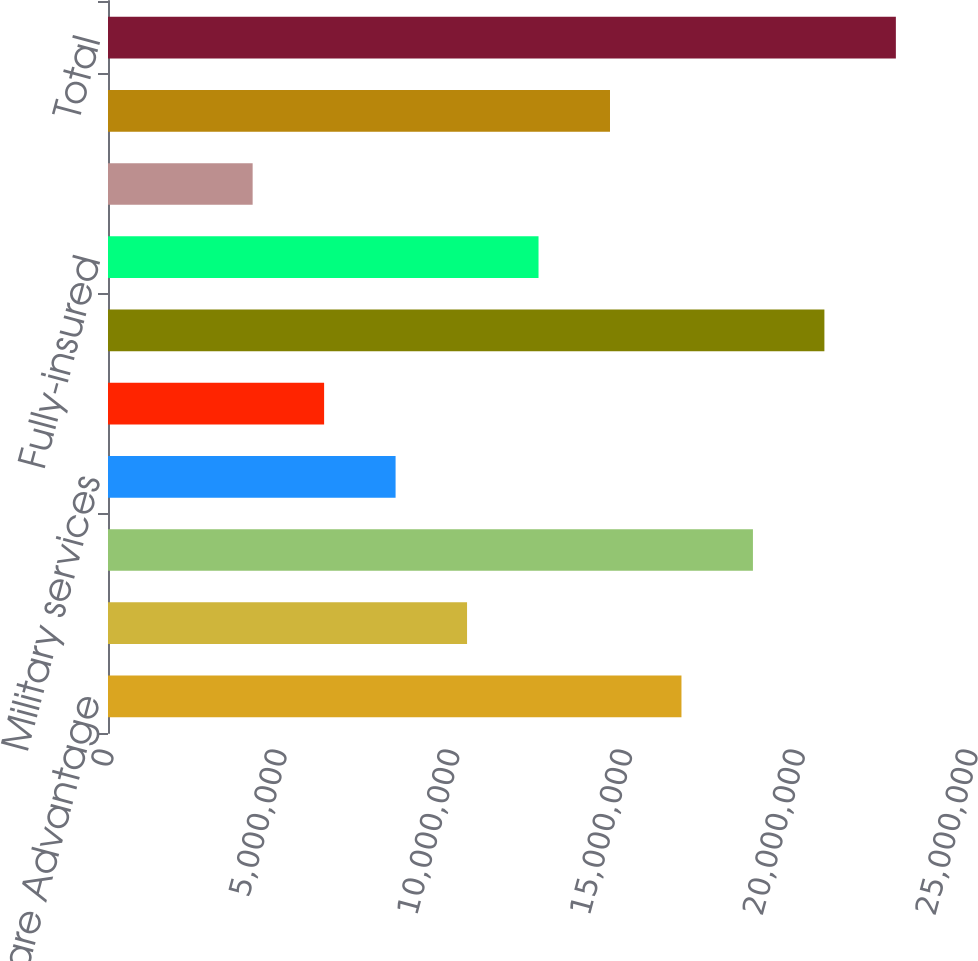<chart> <loc_0><loc_0><loc_500><loc_500><bar_chart><fcel>Medicare Advantage<fcel>Medicare stand-alone PDP<fcel>Total Medicare<fcel>Military services<fcel>Medicaid<fcel>Total Government<fcel>Fully-insured<fcel>Specialty<fcel>Total Commercial<fcel>Total<nl><fcel>1.65932e+07<fcel>1.03893e+07<fcel>1.86612e+07<fcel>8.32134e+06<fcel>6.25336e+06<fcel>2.07292e+07<fcel>1.24573e+07<fcel>4.18539e+06<fcel>1.45253e+07<fcel>2.27972e+07<nl></chart> 